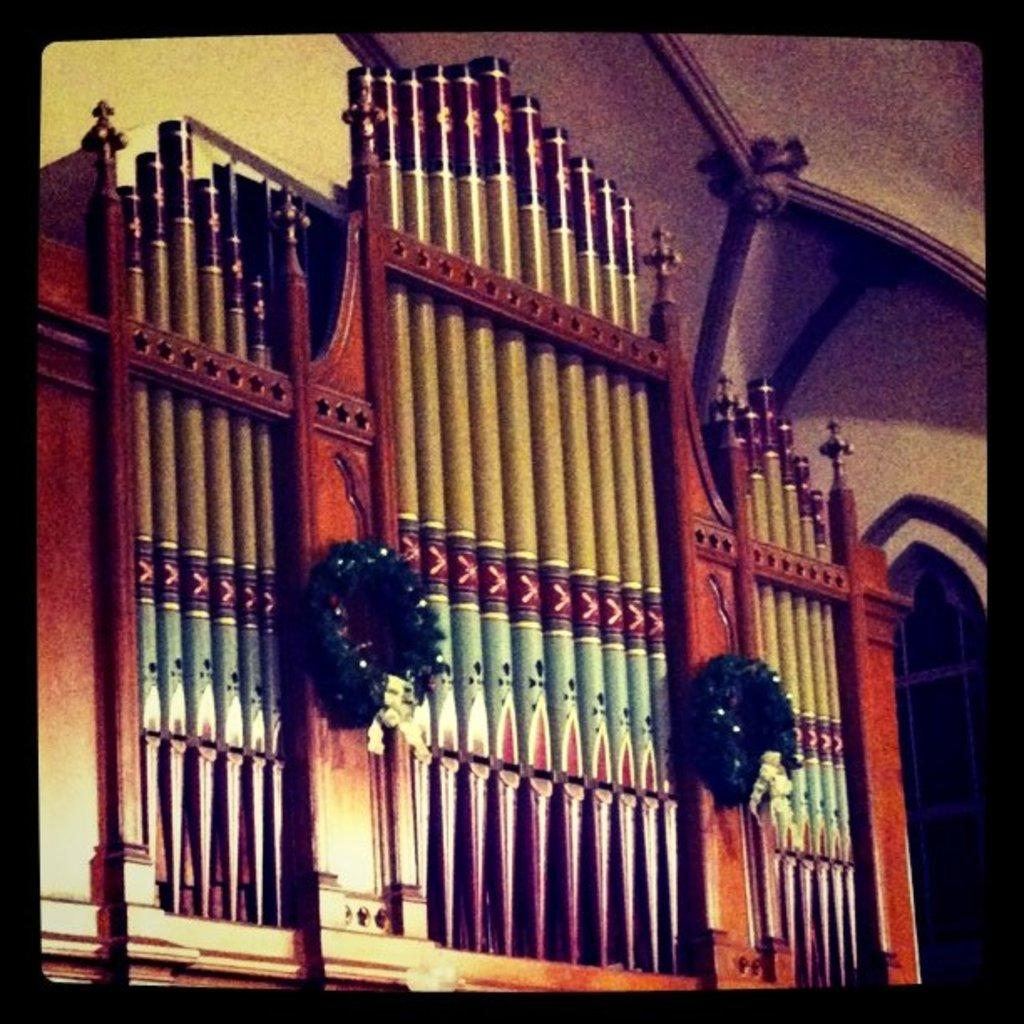What is the main structure in the image? There is a wooden frame in the image. What decorations are on the wooden frame? There are two garlands on the wooden frame. What type of background can be seen in the image? Walls are visible in the image. What is the color of the border surrounding the image? The image has a black color border. What is the aftermath of the event depicted in the image? There is no event depicted in the image, as it only shows a wooden frame with garlands and a black border. In which direction does the wooden frame face in the image? The image does not provide information about the direction the wooden frame faces, as it only shows the frame and its decorations. 